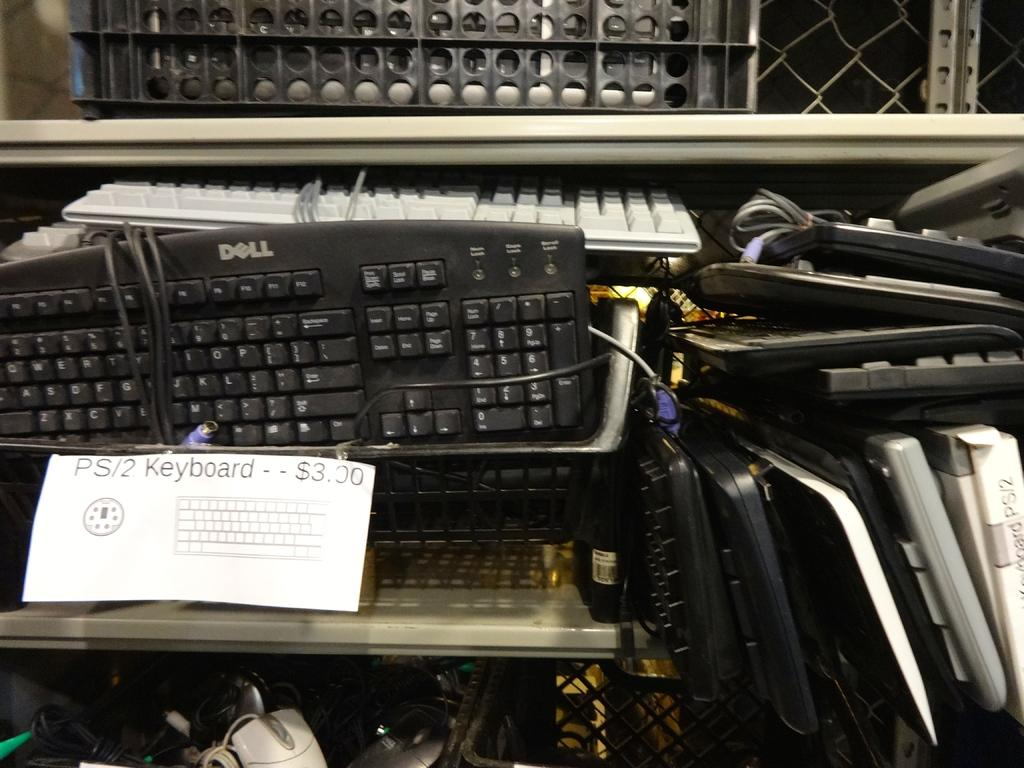<image>
Offer a succinct explanation of the picture presented. Lots of computer keyboards including some by Dell are on a shelf. 